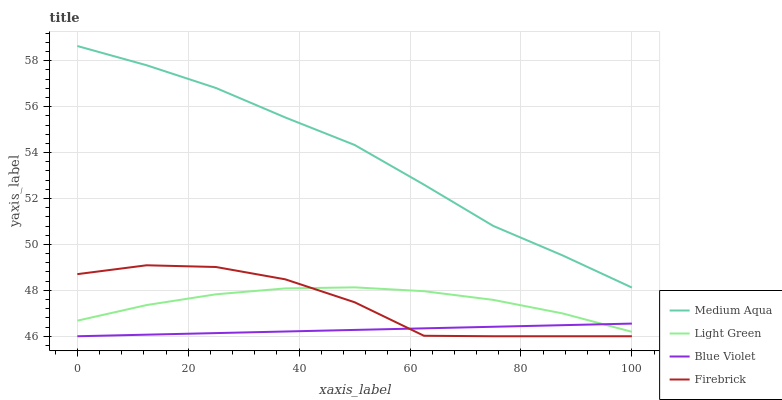Does Blue Violet have the minimum area under the curve?
Answer yes or no. Yes. Does Medium Aqua have the maximum area under the curve?
Answer yes or no. Yes. Does Medium Aqua have the minimum area under the curve?
Answer yes or no. No. Does Blue Violet have the maximum area under the curve?
Answer yes or no. No. Is Blue Violet the smoothest?
Answer yes or no. Yes. Is Firebrick the roughest?
Answer yes or no. Yes. Is Medium Aqua the smoothest?
Answer yes or no. No. Is Medium Aqua the roughest?
Answer yes or no. No. Does Firebrick have the lowest value?
Answer yes or no. Yes. Does Medium Aqua have the lowest value?
Answer yes or no. No. Does Medium Aqua have the highest value?
Answer yes or no. Yes. Does Blue Violet have the highest value?
Answer yes or no. No. Is Firebrick less than Medium Aqua?
Answer yes or no. Yes. Is Medium Aqua greater than Firebrick?
Answer yes or no. Yes. Does Light Green intersect Blue Violet?
Answer yes or no. Yes. Is Light Green less than Blue Violet?
Answer yes or no. No. Is Light Green greater than Blue Violet?
Answer yes or no. No. Does Firebrick intersect Medium Aqua?
Answer yes or no. No. 